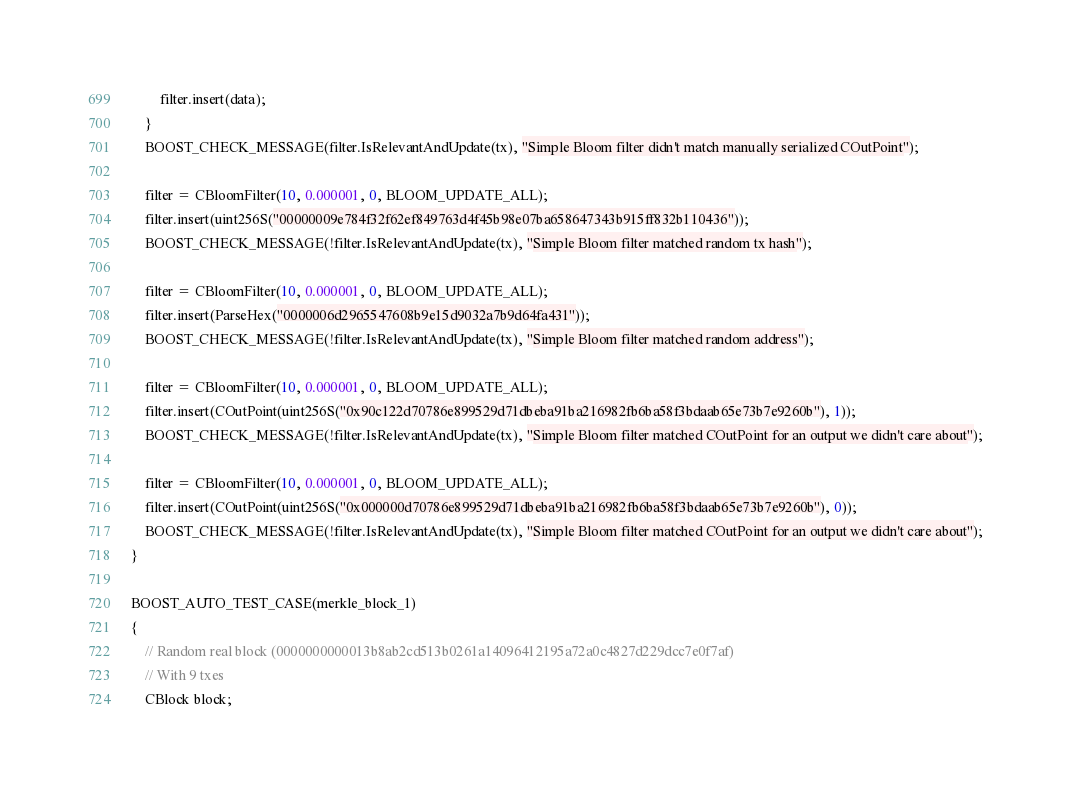Convert code to text. <code><loc_0><loc_0><loc_500><loc_500><_C++_>        filter.insert(data);
    }
    BOOST_CHECK_MESSAGE(filter.IsRelevantAndUpdate(tx), "Simple Bloom filter didn't match manually serialized COutPoint");

    filter = CBloomFilter(10, 0.000001, 0, BLOOM_UPDATE_ALL);
    filter.insert(uint256S("00000009e784f32f62ef849763d4f45b98e07ba658647343b915ff832b110436"));
    BOOST_CHECK_MESSAGE(!filter.IsRelevantAndUpdate(tx), "Simple Bloom filter matched random tx hash");

    filter = CBloomFilter(10, 0.000001, 0, BLOOM_UPDATE_ALL);
    filter.insert(ParseHex("0000006d2965547608b9e15d9032a7b9d64fa431"));
    BOOST_CHECK_MESSAGE(!filter.IsRelevantAndUpdate(tx), "Simple Bloom filter matched random address");

    filter = CBloomFilter(10, 0.000001, 0, BLOOM_UPDATE_ALL);
    filter.insert(COutPoint(uint256S("0x90c122d70786e899529d71dbeba91ba216982fb6ba58f3bdaab65e73b7e9260b"), 1));
    BOOST_CHECK_MESSAGE(!filter.IsRelevantAndUpdate(tx), "Simple Bloom filter matched COutPoint for an output we didn't care about");

    filter = CBloomFilter(10, 0.000001, 0, BLOOM_UPDATE_ALL);
    filter.insert(COutPoint(uint256S("0x000000d70786e899529d71dbeba91ba216982fb6ba58f3bdaab65e73b7e9260b"), 0));
    BOOST_CHECK_MESSAGE(!filter.IsRelevantAndUpdate(tx), "Simple Bloom filter matched COutPoint for an output we didn't care about");
}

BOOST_AUTO_TEST_CASE(merkle_block_1)
{
    // Random real block (0000000000013b8ab2cd513b0261a14096412195a72a0c4827d229dcc7e0f7af)
    // With 9 txes
    CBlock block;</code> 